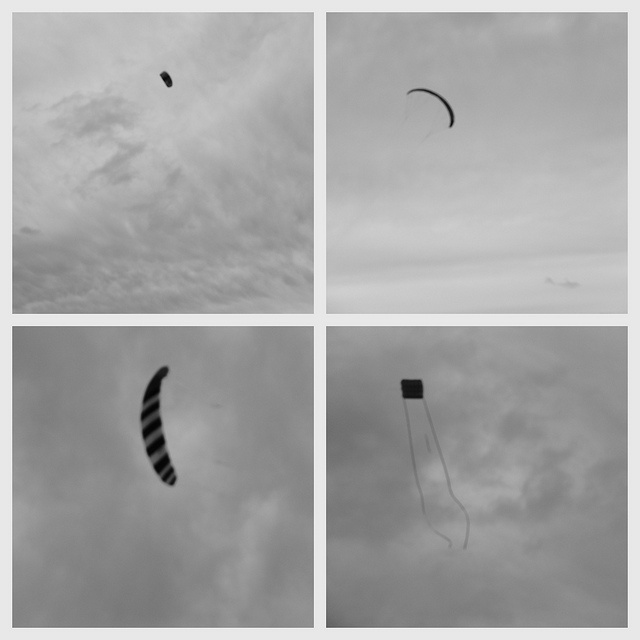Describe the objects in this image and their specific colors. I can see kite in black, gray, and lightgray tones, kite in gray, black, and lightgray tones, kite in gray, black, and lightgray tones, and kite in black, gray, darkgray, and lightgray tones in this image. 